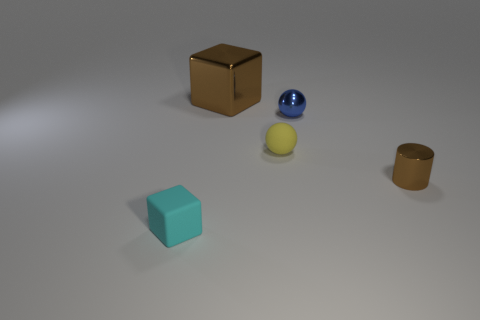The brown object that is on the left side of the brown shiny cylinder has what shape?
Make the answer very short. Cube. There is a ball in front of the tiny metallic thing behind the tiny cylinder; what is its color?
Give a very brief answer. Yellow. How many things are matte objects in front of the tiny yellow matte ball or small shiny cylinders?
Give a very brief answer. 2. There is a yellow matte ball; is its size the same as the object on the left side of the big metallic block?
Provide a short and direct response. Yes. What number of big things are either cyan objects or gray balls?
Your answer should be very brief. 0. The small yellow matte thing has what shape?
Offer a terse response. Sphere. There is a thing that is the same color as the large block; what is its size?
Ensure brevity in your answer.  Small. Is there a big thing made of the same material as the tiny blue object?
Ensure brevity in your answer.  Yes. Is the number of metal objects greater than the number of brown metallic things?
Provide a succinct answer. Yes. Do the tiny blue thing and the cyan block have the same material?
Offer a terse response. No. 